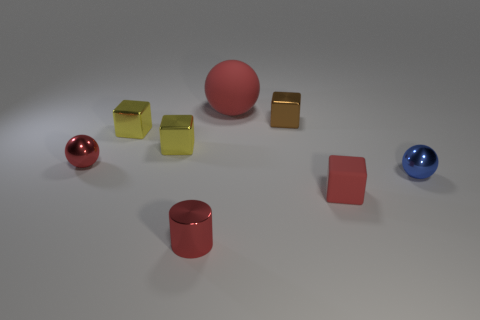Subtract 1 blocks. How many blocks are left? 3 Add 1 tiny metallic cylinders. How many objects exist? 9 Subtract all cylinders. How many objects are left? 7 Add 1 metallic cylinders. How many metallic cylinders are left? 2 Add 6 red metallic cylinders. How many red metallic cylinders exist? 7 Subtract 0 blue cylinders. How many objects are left? 8 Subtract all purple rubber blocks. Subtract all small cylinders. How many objects are left? 7 